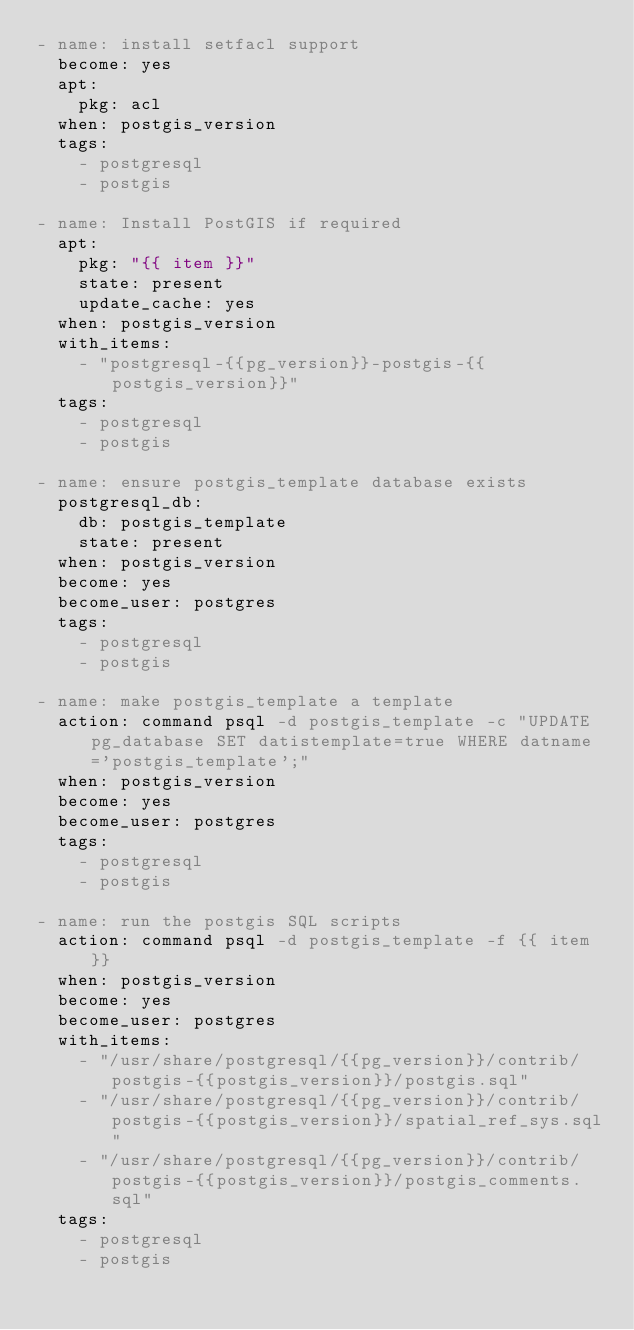<code> <loc_0><loc_0><loc_500><loc_500><_YAML_>- name: install setfacl support
  become: yes
  apt:
    pkg: acl
  when: postgis_version
  tags:
    - postgresql
    - postgis

- name: Install PostGIS if required
  apt:
    pkg: "{{ item }}"
    state: present
    update_cache: yes
  when: postgis_version
  with_items:
    - "postgresql-{{pg_version}}-postgis-{{postgis_version}}"
  tags:
    - postgresql
    - postgis

- name: ensure postgis_template database exists
  postgresql_db:
    db: postgis_template
    state: present
  when: postgis_version
  become: yes
  become_user: postgres
  tags:
    - postgresql
    - postgis

- name: make postgis_template a template
  action: command psql -d postgis_template -c "UPDATE pg_database SET datistemplate=true WHERE datname='postgis_template';"
  when: postgis_version
  become: yes
  become_user: postgres
  tags:
    - postgresql
    - postgis

- name: run the postgis SQL scripts
  action: command psql -d postgis_template -f {{ item }}
  when: postgis_version
  become: yes
  become_user: postgres
  with_items:
    - "/usr/share/postgresql/{{pg_version}}/contrib/postgis-{{postgis_version}}/postgis.sql"
    - "/usr/share/postgresql/{{pg_version}}/contrib/postgis-{{postgis_version}}/spatial_ref_sys.sql"
    - "/usr/share/postgresql/{{pg_version}}/contrib/postgis-{{postgis_version}}/postgis_comments.sql"
  tags:
    - postgresql
    - postgis
</code> 